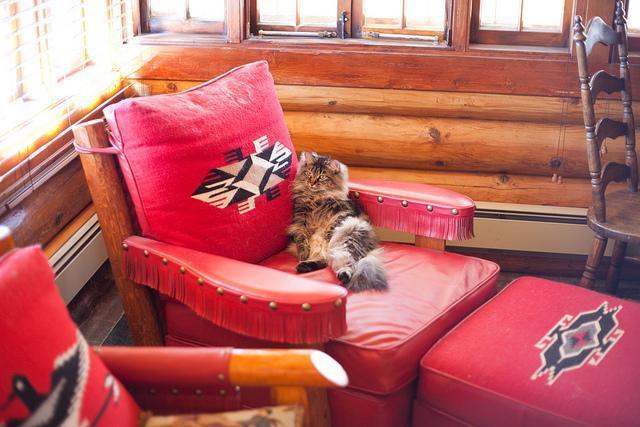How many chairs are there?
Give a very brief answer. 3. 